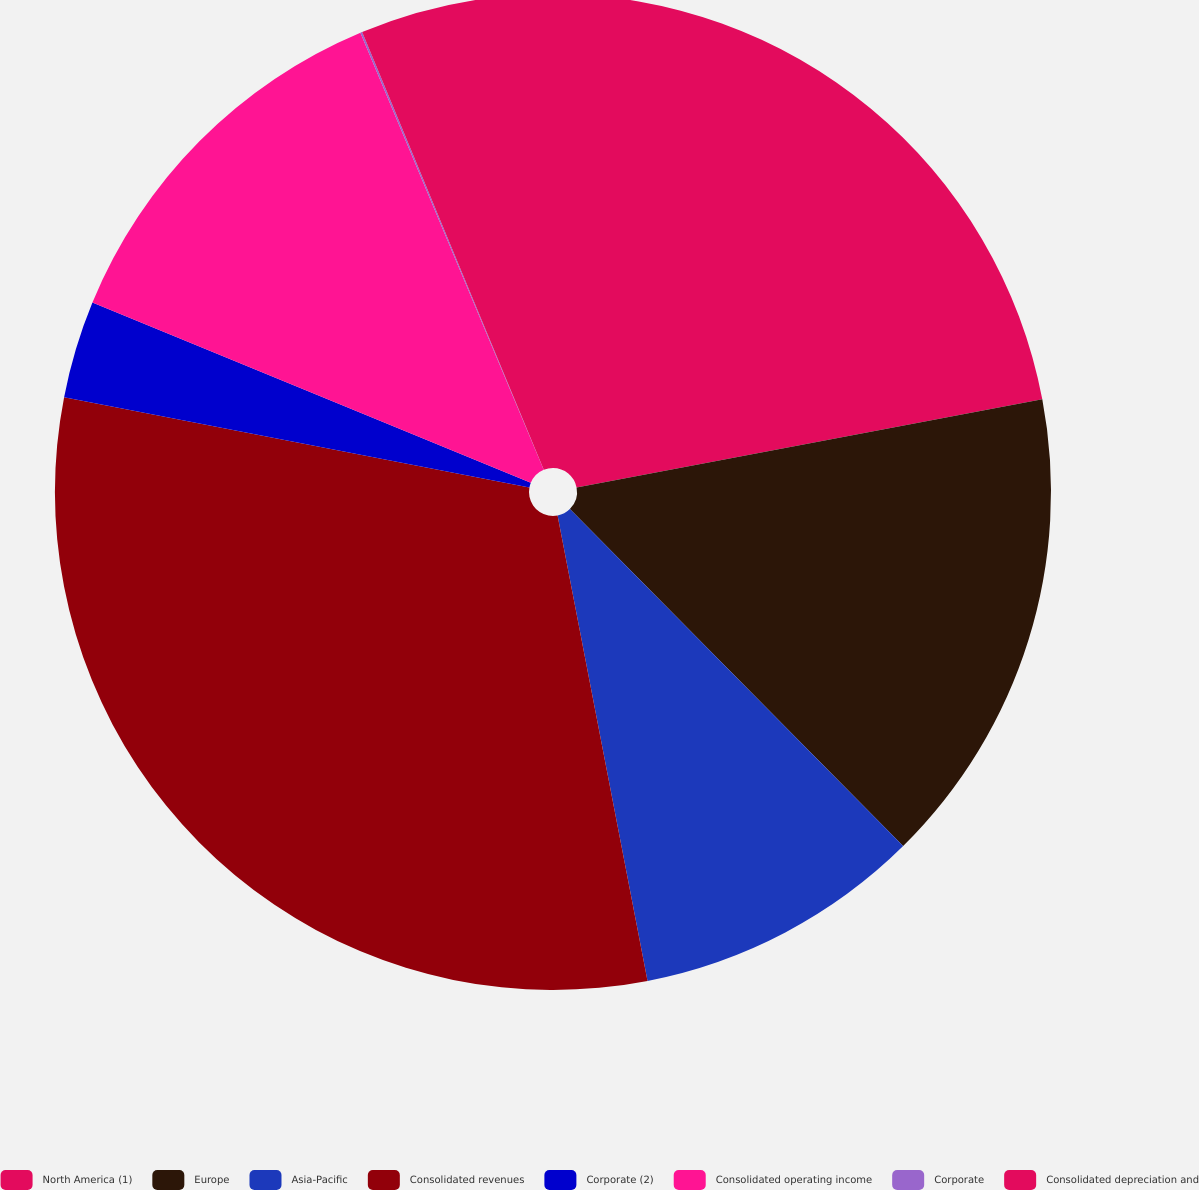Convert chart to OTSL. <chart><loc_0><loc_0><loc_500><loc_500><pie_chart><fcel>North America (1)<fcel>Europe<fcel>Asia-Pacific<fcel>Consolidated revenues<fcel>Corporate (2)<fcel>Consolidated operating income<fcel>Corporate<fcel>Consolidated depreciation and<nl><fcel>22.02%<fcel>15.57%<fcel>9.37%<fcel>31.09%<fcel>3.16%<fcel>12.47%<fcel>0.06%<fcel>6.26%<nl></chart> 